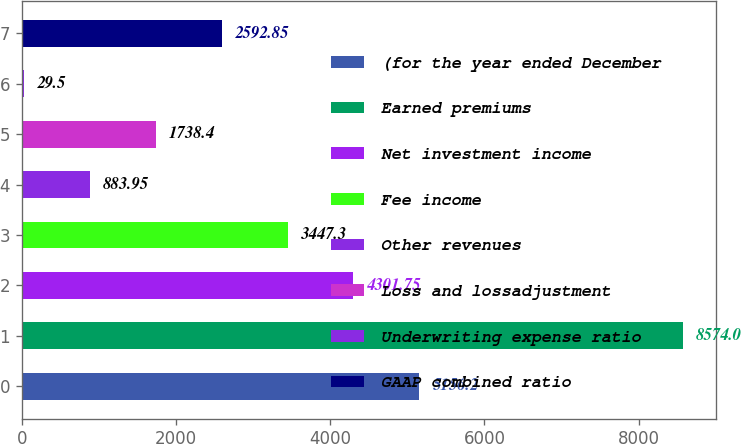Convert chart to OTSL. <chart><loc_0><loc_0><loc_500><loc_500><bar_chart><fcel>(for the year ended December<fcel>Earned premiums<fcel>Net investment income<fcel>Fee income<fcel>Other revenues<fcel>Loss and lossadjustment<fcel>Underwriting expense ratio<fcel>GAAP combined ratio<nl><fcel>5156.2<fcel>8574<fcel>4301.75<fcel>3447.3<fcel>883.95<fcel>1738.4<fcel>29.5<fcel>2592.85<nl></chart> 